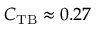<formula> <loc_0><loc_0><loc_500><loc_500>C _ { T B } \approx 0 . 2 7</formula> 